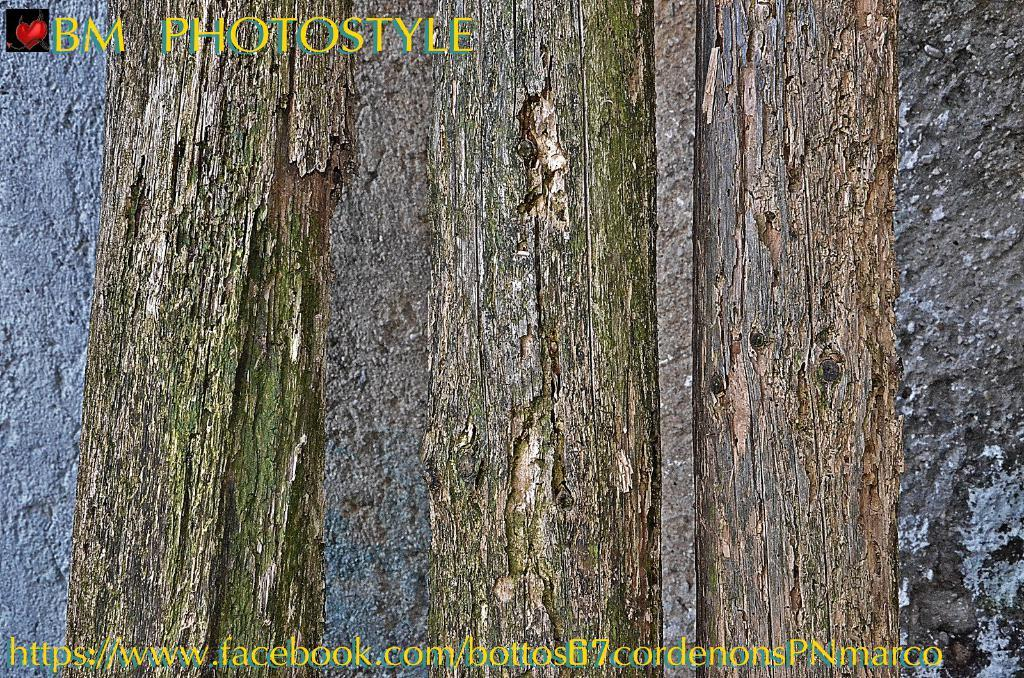What type of natural elements can be seen in the image? The image contains trees. What can be seen in the background of the image? There is a wall in the background of the image. Is there any text present in the image? Yes, there is text at the bottom of the image. What type of cloth is draped over the trees in the image? There is no cloth draped over the trees in the image; only trees and a wall are visible. 